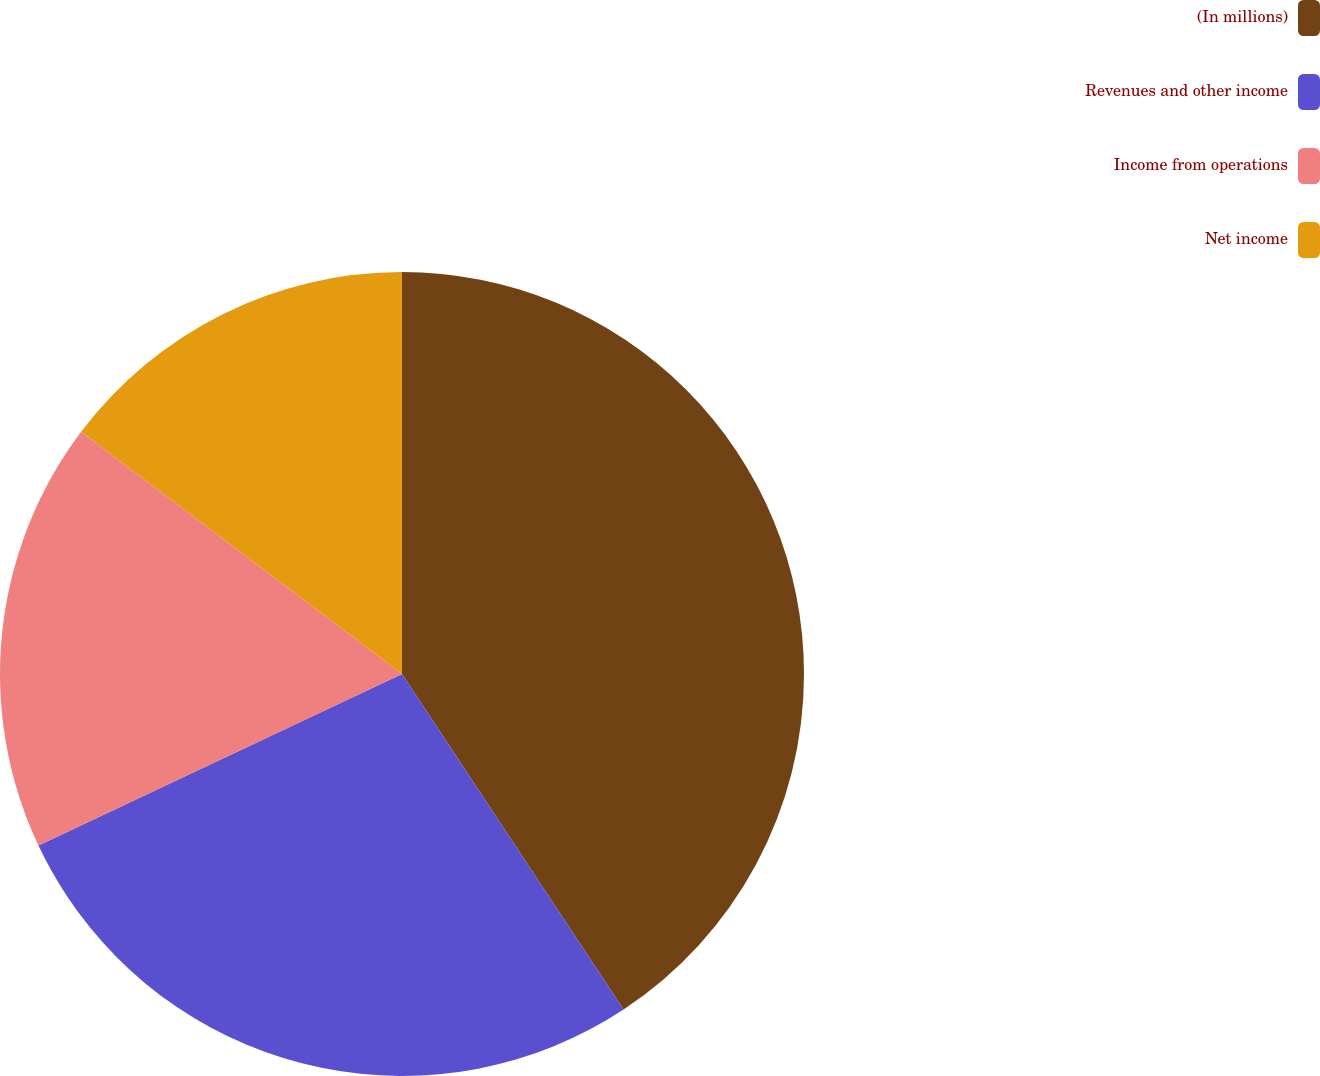Convert chart. <chart><loc_0><loc_0><loc_500><loc_500><pie_chart><fcel>(In millions)<fcel>Revenues and other income<fcel>Income from operations<fcel>Net income<nl><fcel>40.71%<fcel>27.27%<fcel>17.31%<fcel>14.71%<nl></chart> 